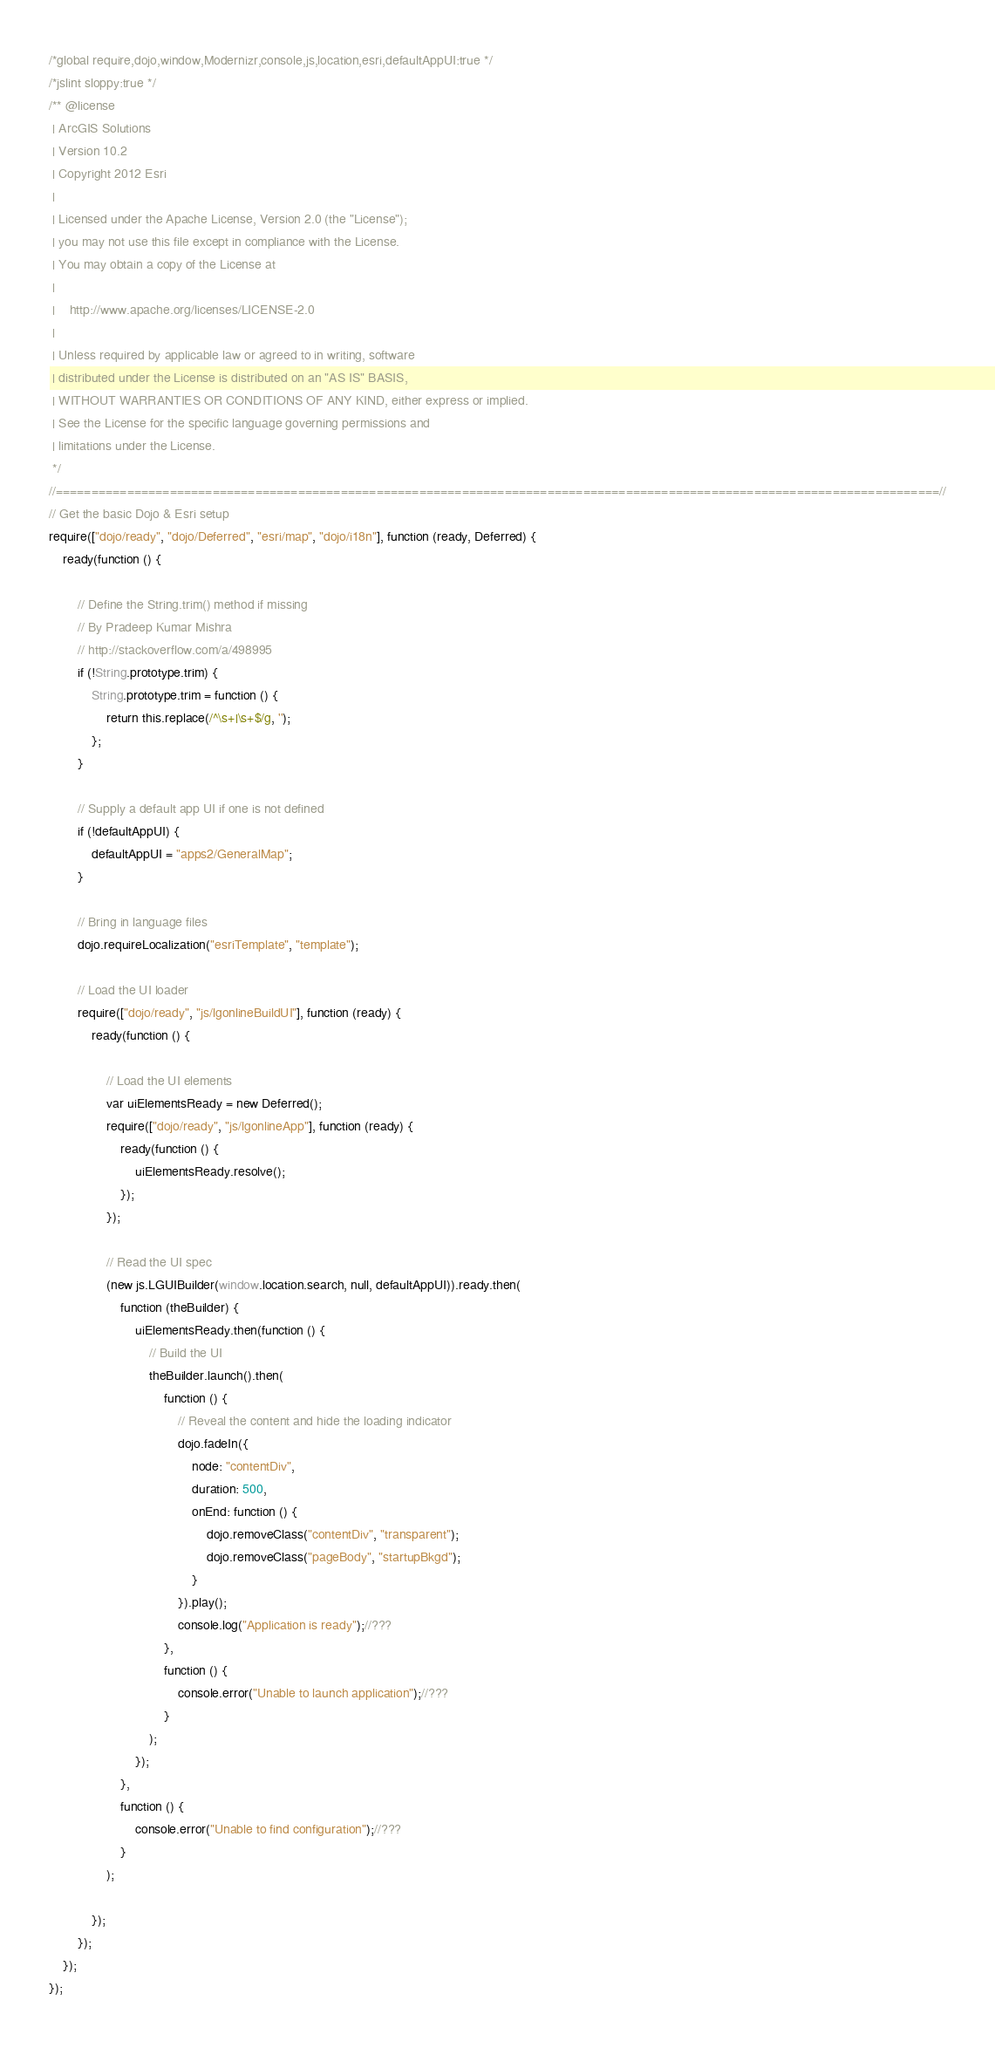<code> <loc_0><loc_0><loc_500><loc_500><_JavaScript_>/*global require,dojo,window,Modernizr,console,js,location,esri,defaultAppUI:true */
/*jslint sloppy:true */
/** @license
 | ArcGIS Solutions
 | Version 10.2
 | Copyright 2012 Esri
 |
 | Licensed under the Apache License, Version 2.0 (the "License");
 | you may not use this file except in compliance with the License.
 | You may obtain a copy of the License at
 |
 |    http://www.apache.org/licenses/LICENSE-2.0
 |
 | Unless required by applicable law or agreed to in writing, software
 | distributed under the License is distributed on an "AS IS" BASIS,
 | WITHOUT WARRANTIES OR CONDITIONS OF ANY KIND, either express or implied.
 | See the License for the specific language governing permissions and
 | limitations under the License.
 */
//============================================================================================================================//
// Get the basic Dojo & Esri setup
require(["dojo/ready", "dojo/Deferred", "esri/map", "dojo/i18n"], function (ready, Deferred) {
    ready(function () {

        // Define the String.trim() method if missing
        // By Pradeep Kumar Mishra
        // http://stackoverflow.com/a/498995
        if (!String.prototype.trim) {
            String.prototype.trim = function () {
                return this.replace(/^\s+|\s+$/g, '');
            };
        }

        // Supply a default app UI if one is not defined
        if (!defaultAppUI) {
            defaultAppUI = "apps2/GeneralMap";
        }

        // Bring in language files
        dojo.requireLocalization("esriTemplate", "template");

        // Load the UI loader
        require(["dojo/ready", "js/lgonlineBuildUI"], function (ready) {
            ready(function () {

                // Load the UI elements
                var uiElementsReady = new Deferred();
                require(["dojo/ready", "js/lgonlineApp"], function (ready) {
                    ready(function () {
                        uiElementsReady.resolve();
                    });
                });

                // Read the UI spec
                (new js.LGUIBuilder(window.location.search, null, defaultAppUI)).ready.then(
                    function (theBuilder) {
                        uiElementsReady.then(function () {
                            // Build the UI
                            theBuilder.launch().then(
                                function () {
                                    // Reveal the content and hide the loading indicator
                                    dojo.fadeIn({
                                        node: "contentDiv",
                                        duration: 500,
                                        onEnd: function () {
                                            dojo.removeClass("contentDiv", "transparent");
                                            dojo.removeClass("pageBody", "startupBkgd");
                                        }
                                    }).play();
                                    console.log("Application is ready");//???
                                },
                                function () {
                                    console.error("Unable to launch application");//???
                                }
                            );
                        });
                    },
                    function () {
                        console.error("Unable to find configuration");//???
                    }
                );

            });
        });
    });
});
</code> 